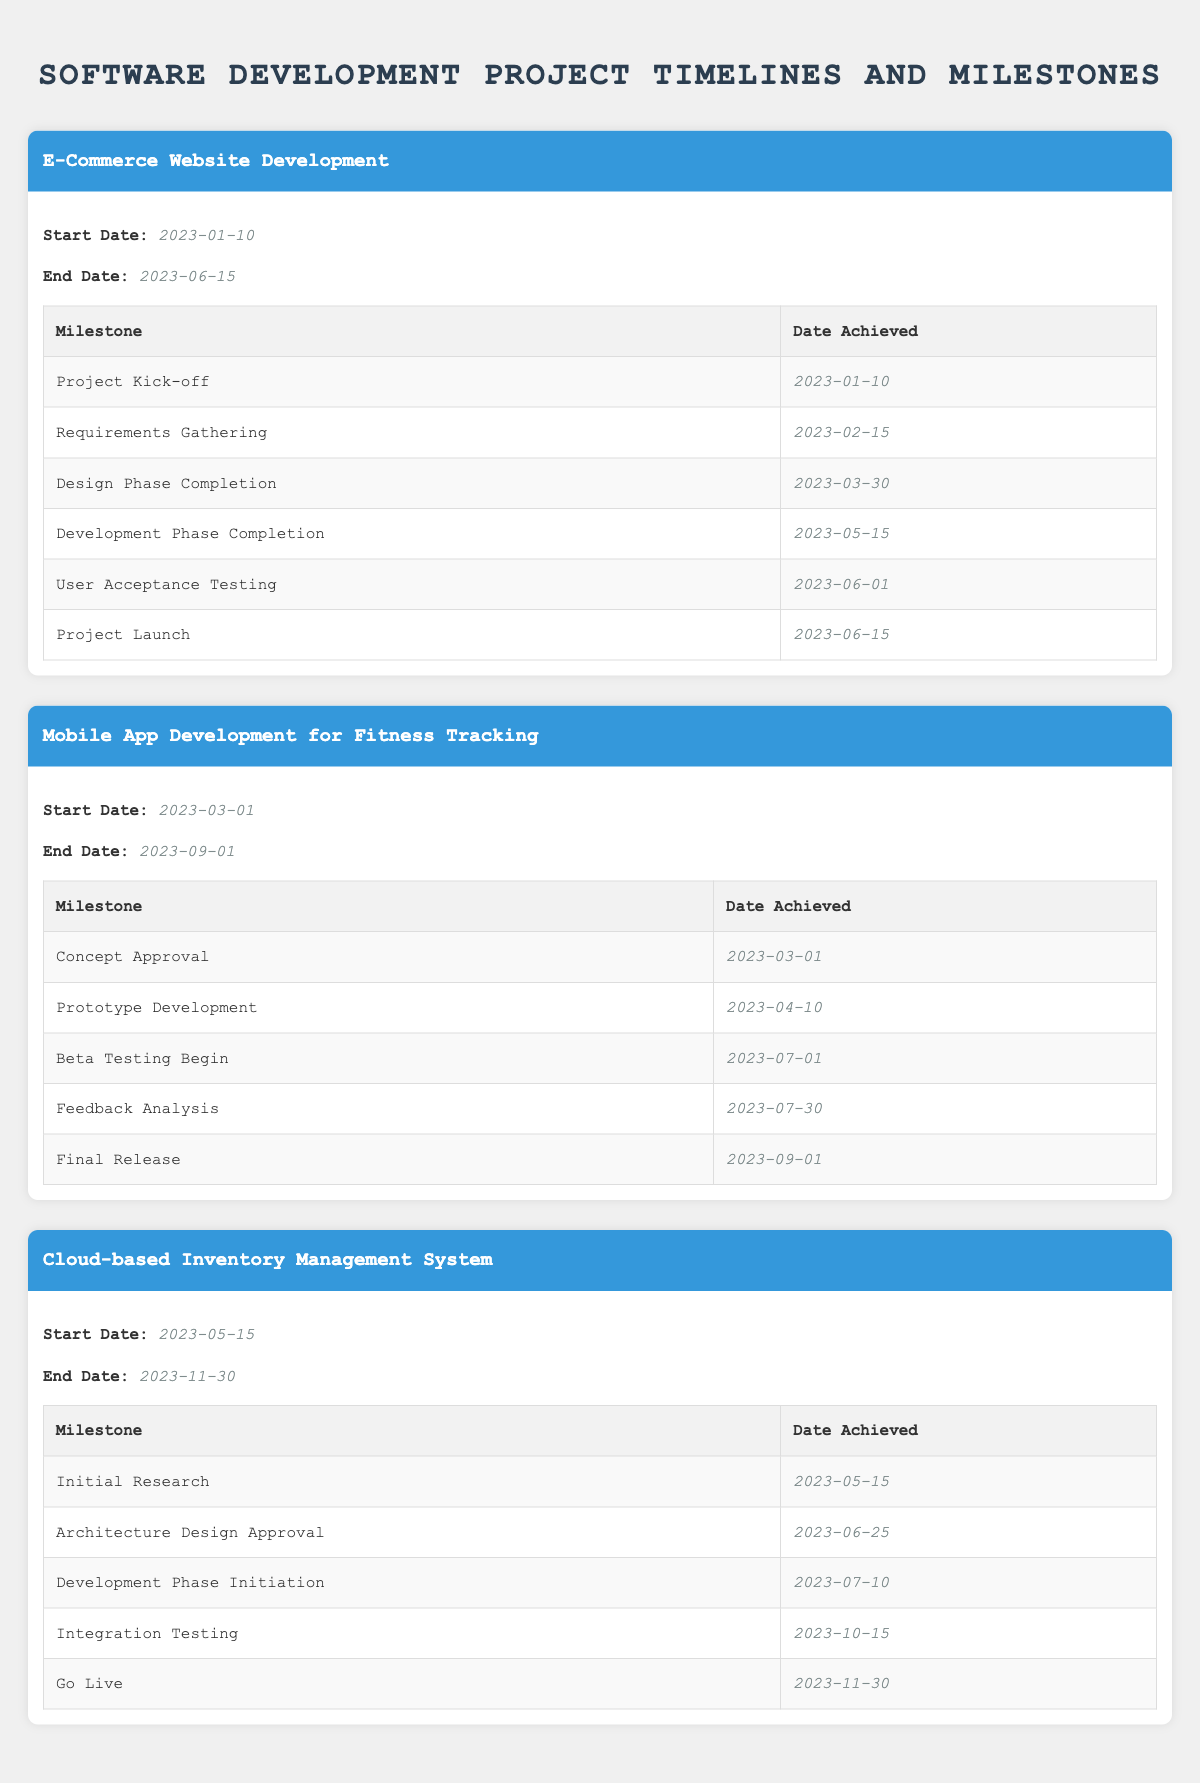What is the end date of the E-Commerce Website Development project? The end date is listed under the project details of the E-Commerce Website Development project. It is stated as 2023-06-15.
Answer: 2023-06-15 How many milestones are there in the Mobile App Development project? The table indicates that there are five milestones listed under the Mobile App Development for Fitness Tracking project.
Answer: 5 Is the Development Phase Completion milestone achieved before the User Acceptance Testing milestone in the E-Commerce Website project? By comparing the dates of the milestones, Development Phase Completion is on 2023-05-15, while User Acceptance Testing is on 2023-06-01. Therefore, Development Phase Completion is achieved before User Acceptance Testing.
Answer: Yes What is the duration of the Cloud-based Inventory Management System project in days? The project starts on 2023-05-15 and ends on 2023-11-30. Calculating the duration involves counting the days from the start to the end date, resulting in 199 days.
Answer: 199 days Did the Initial Research milestone in the Cloud-based Inventory Management System project occur on the same day as the project's start date? The Initial Research milestone is reported as achieved on 2023-05-15, which is indeed the same as the project's start date.
Answer: Yes What is the average date achieved for all milestones in the E-Commerce Website Development project? The dates of the milestones are converted into a numeric format, summed up, and divided by the number of milestones. The dates are 2023-01-10 (10), 2023-02-15 (46), 2023-03-30 (89), 2023-05-15 (135), 2023-06-01 (151), and 2023-06-15 (165). The average comes out to (10 + 46 + 89 + 135 + 151 + 165) / 6 = 599 / 6 ≈ 99.83, which corresponds to the date of 2023-02-08.
Answer: 2023-02-08 Which milestone came the earliest in the Cloud-based Inventory Management System project? Checking the milestone dates listed for the Cloud-based Inventory Management System, the earliest is stated as Initial Research on 2023-05-15.
Answer: Initial Research What is the total number of days between the Concept Approval and Final Release milestones in the Mobile App Development project? The Concept Approval milestone is on 2023-03-01, and the Final Release milestone is on 2023-09-01. The total days in between are 184.
Answer: 184 days How many projects had their milestones completed by June 2023? Looking at the milestone completion dates, the E-Commerce project achieved all milestones by June 15, and the Mobile App project has milestones up until September 1. Therefore, only the E-Commerce project has all milestones completed by June 2023.
Answer: 1 project 